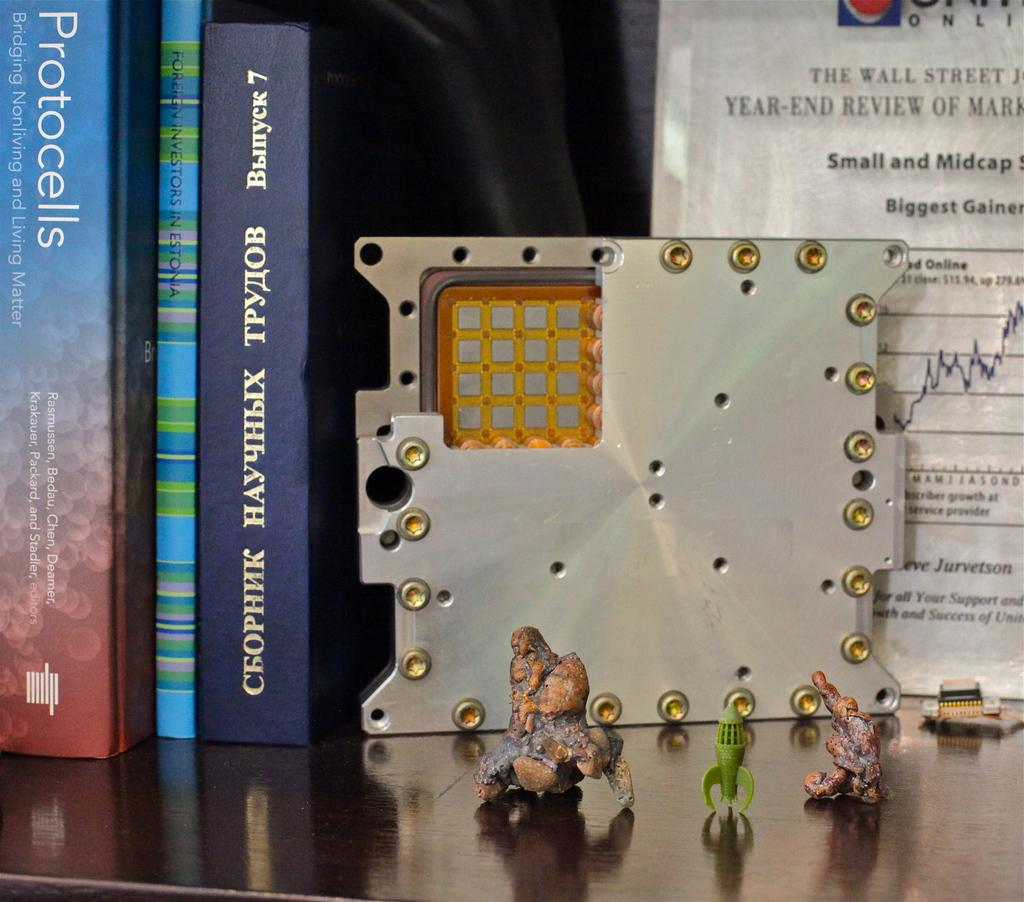<image>
Summarize the visual content of the image. Three books on a shelf one about Protocells, other about investments and  other in Greek, a metal frame and a degree on back. 